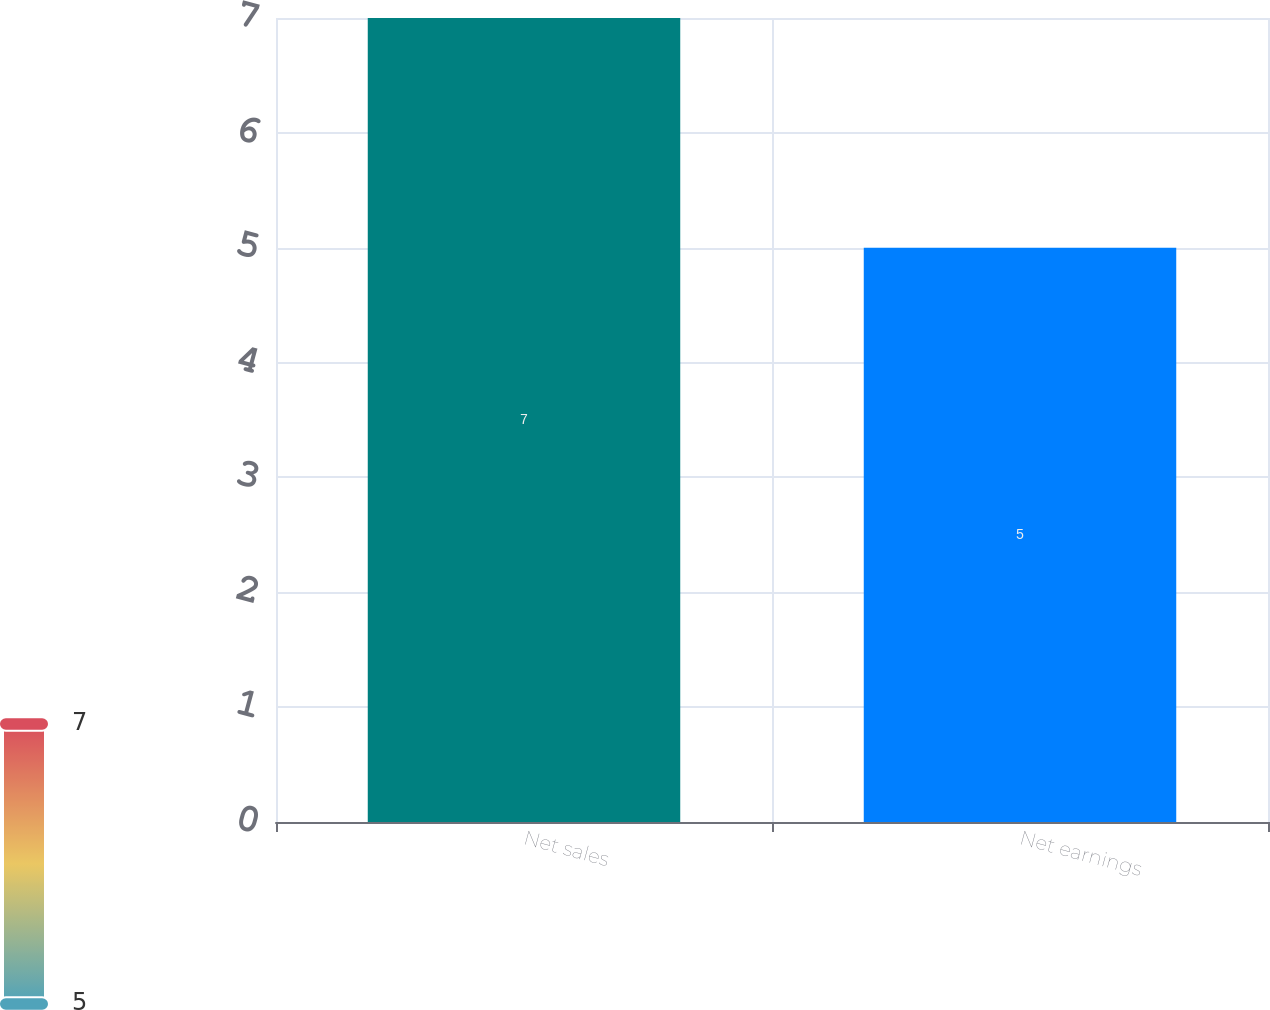Convert chart. <chart><loc_0><loc_0><loc_500><loc_500><bar_chart><fcel>Net sales<fcel>Net earnings<nl><fcel>7<fcel>5<nl></chart> 